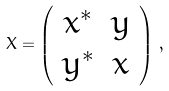Convert formula to latex. <formula><loc_0><loc_0><loc_500><loc_500>X = \left ( \begin{array} { c c } x ^ { * } & y \\ y ^ { * } & x \end{array} \right ) \, ,</formula> 